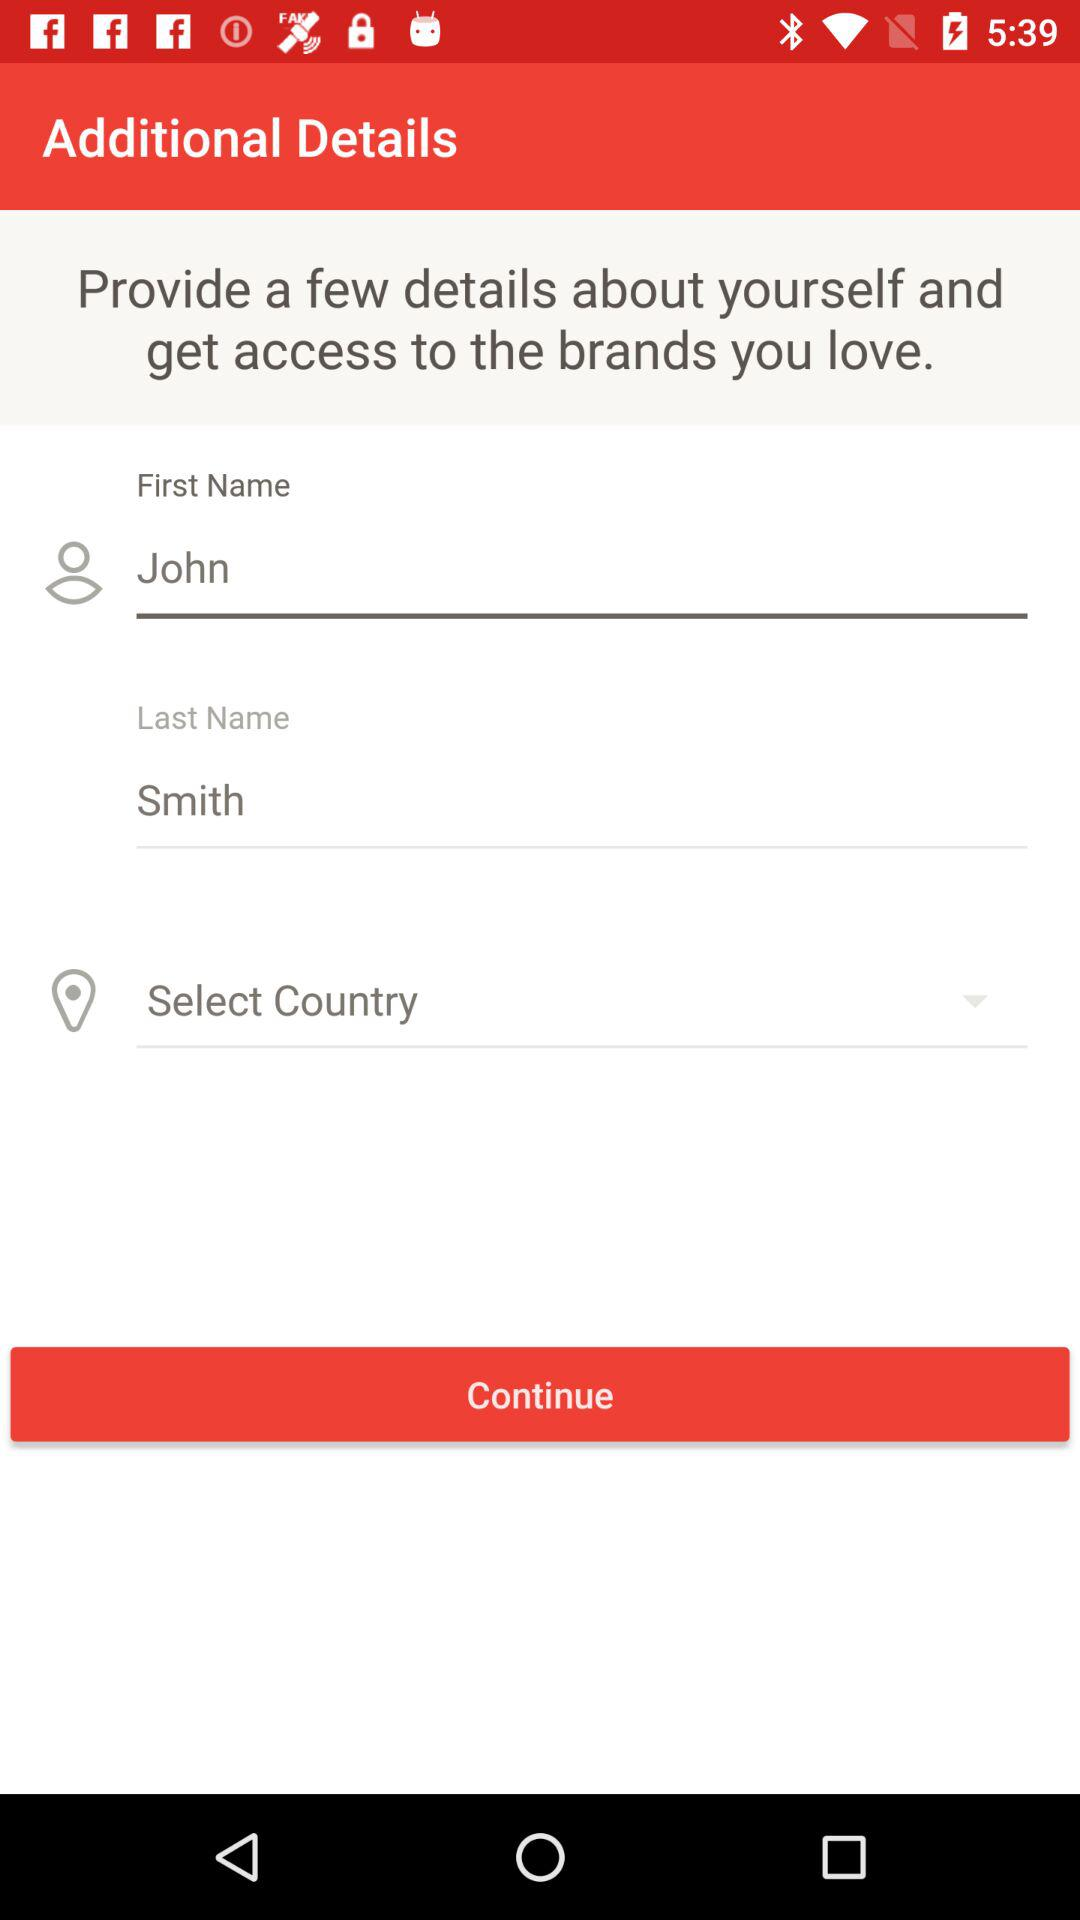What's the user's first name? The user's first name is John. 